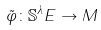<formula> <loc_0><loc_0><loc_500><loc_500>\tilde { \varphi } \colon \mathbb { S } ^ { \lambda } E \rightarrow M</formula> 